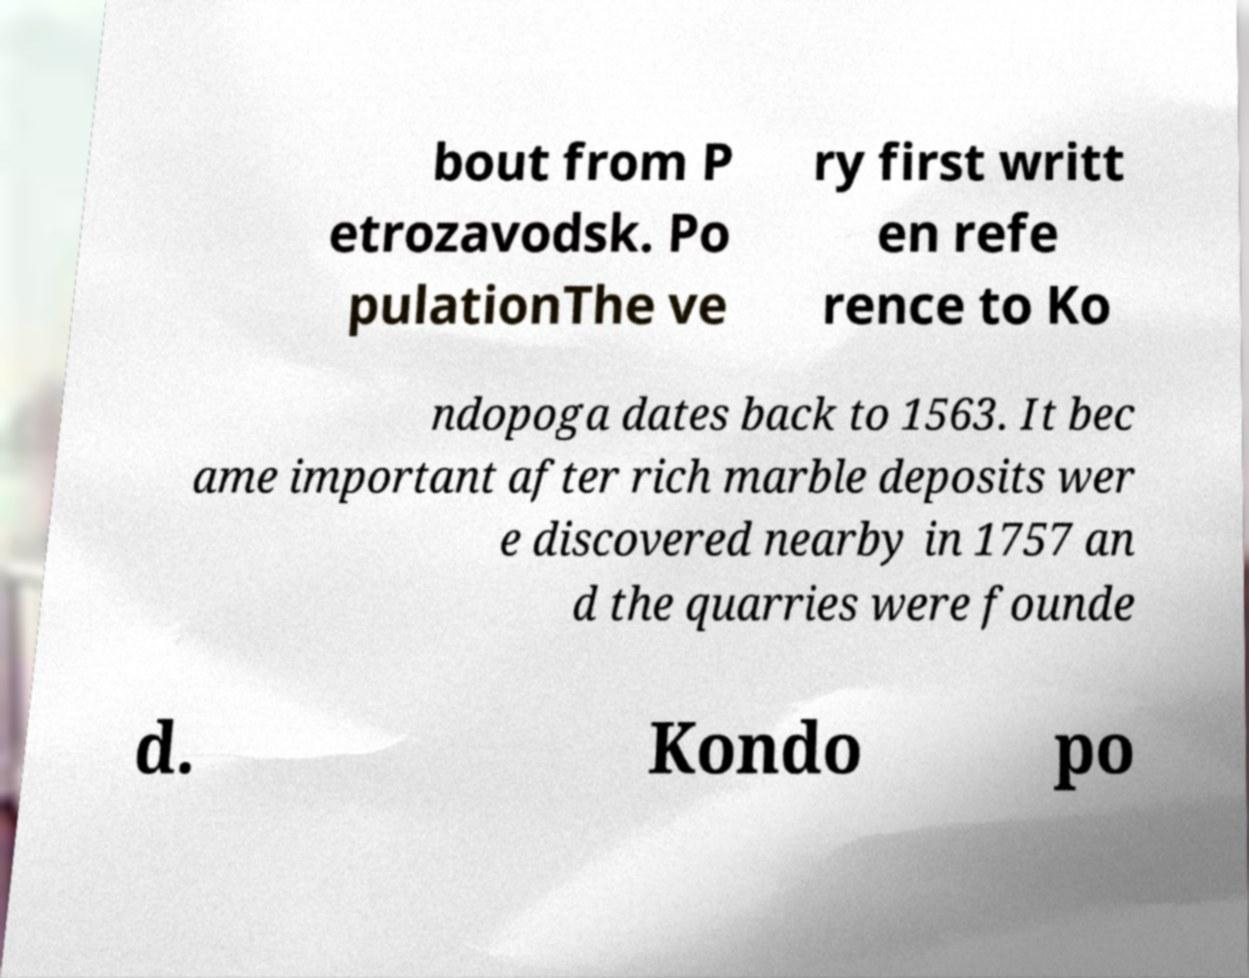Please identify and transcribe the text found in this image. bout from P etrozavodsk. Po pulationThe ve ry first writt en refe rence to Ko ndopoga dates back to 1563. It bec ame important after rich marble deposits wer e discovered nearby in 1757 an d the quarries were founde d. Kondo po 